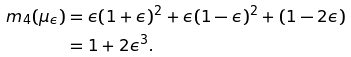Convert formula to latex. <formula><loc_0><loc_0><loc_500><loc_500>m _ { 4 } ( \mu _ { \epsilon } ) & = \epsilon ( 1 + \epsilon ) ^ { 2 } + \epsilon ( 1 - \epsilon ) ^ { 2 } + ( 1 - 2 \epsilon ) \\ & = 1 + 2 \epsilon ^ { 3 } .</formula> 